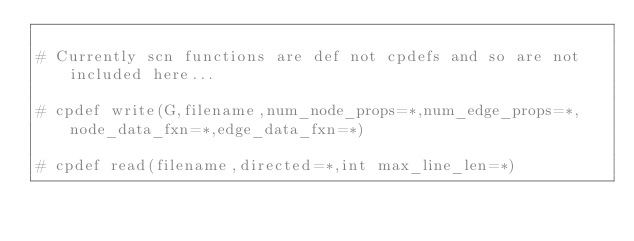<code> <loc_0><loc_0><loc_500><loc_500><_Cython_>
# Currently scn functions are def not cpdefs and so are not included here...

# cpdef write(G,filename,num_node_props=*,num_edge_props=*,node_data_fxn=*,edge_data_fxn=*)

# cpdef read(filename,directed=*,int max_line_len=*)</code> 